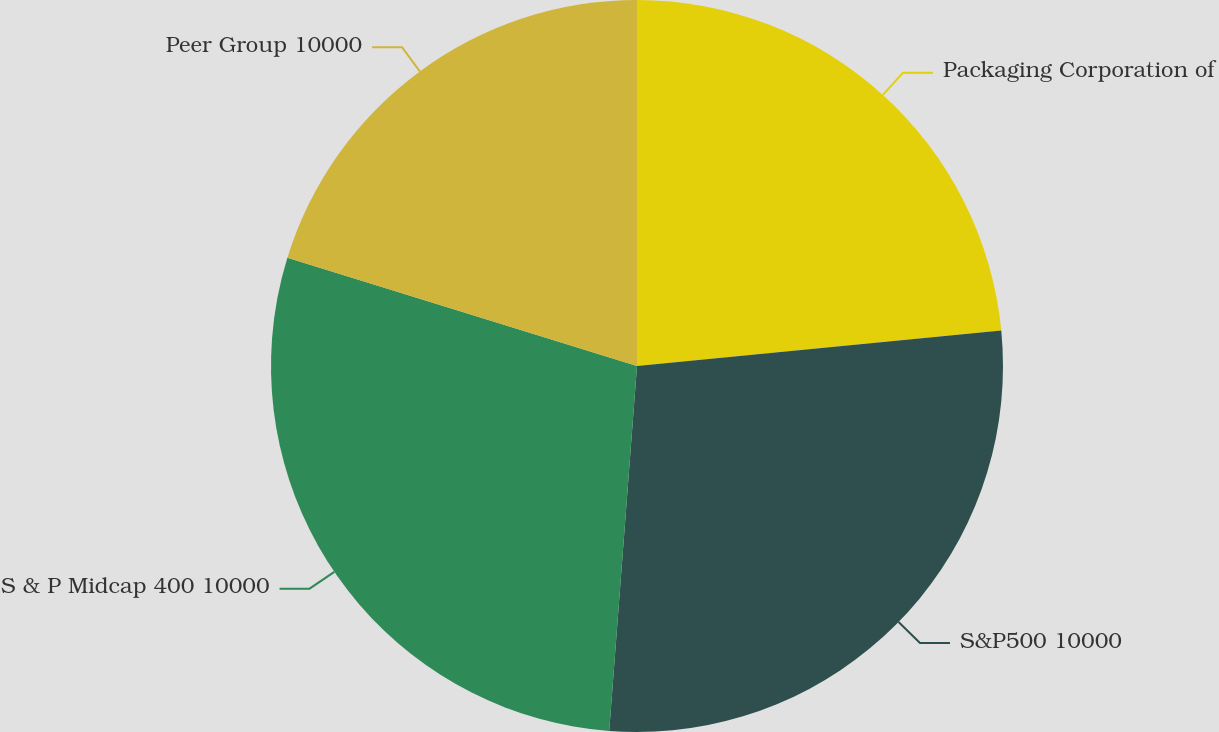Convert chart. <chart><loc_0><loc_0><loc_500><loc_500><pie_chart><fcel>Packaging Corporation of<fcel>S&P500 10000<fcel>S & P Midcap 400 10000<fcel>Peer Group 10000<nl><fcel>23.45%<fcel>27.76%<fcel>28.57%<fcel>20.22%<nl></chart> 